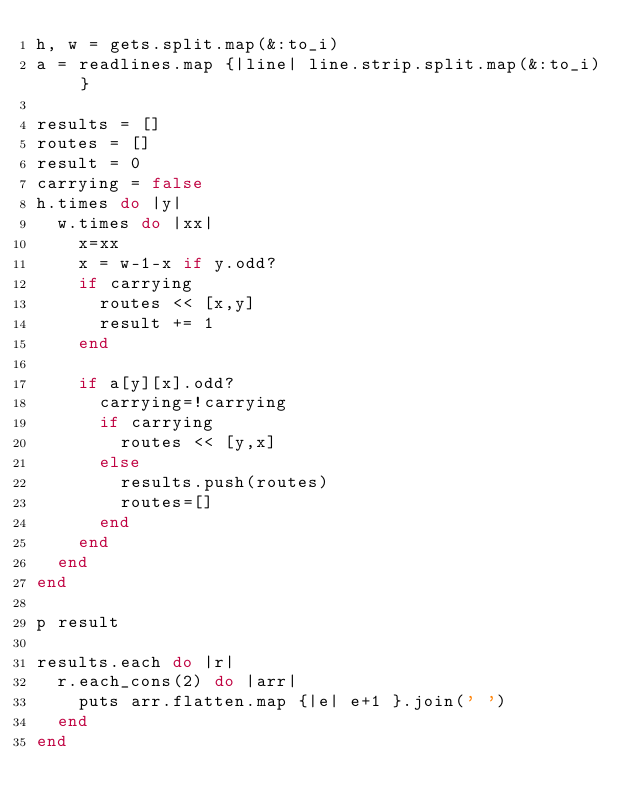Convert code to text. <code><loc_0><loc_0><loc_500><loc_500><_Ruby_>h, w = gets.split.map(&:to_i)
a = readlines.map {|line| line.strip.split.map(&:to_i) }

results = []
routes = []
result = 0
carrying = false
h.times do |y|
  w.times do |xx|
    x=xx
    x = w-1-x if y.odd?
    if carrying
      routes << [x,y]
      result += 1
    end

    if a[y][x].odd?
      carrying=!carrying
      if carrying
        routes << [y,x]
      else
        results.push(routes)
        routes=[]
      end
    end
  end
end

p result

results.each do |r|
  r.each_cons(2) do |arr|
    puts arr.flatten.map {|e| e+1 }.join(' ')
  end
end
</code> 